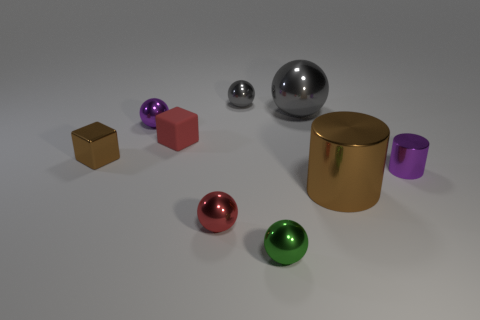How many objects are there in total in this image? There are a total of seven objects in the image, including a variety of spheres and blocks with different colors and finishes. 